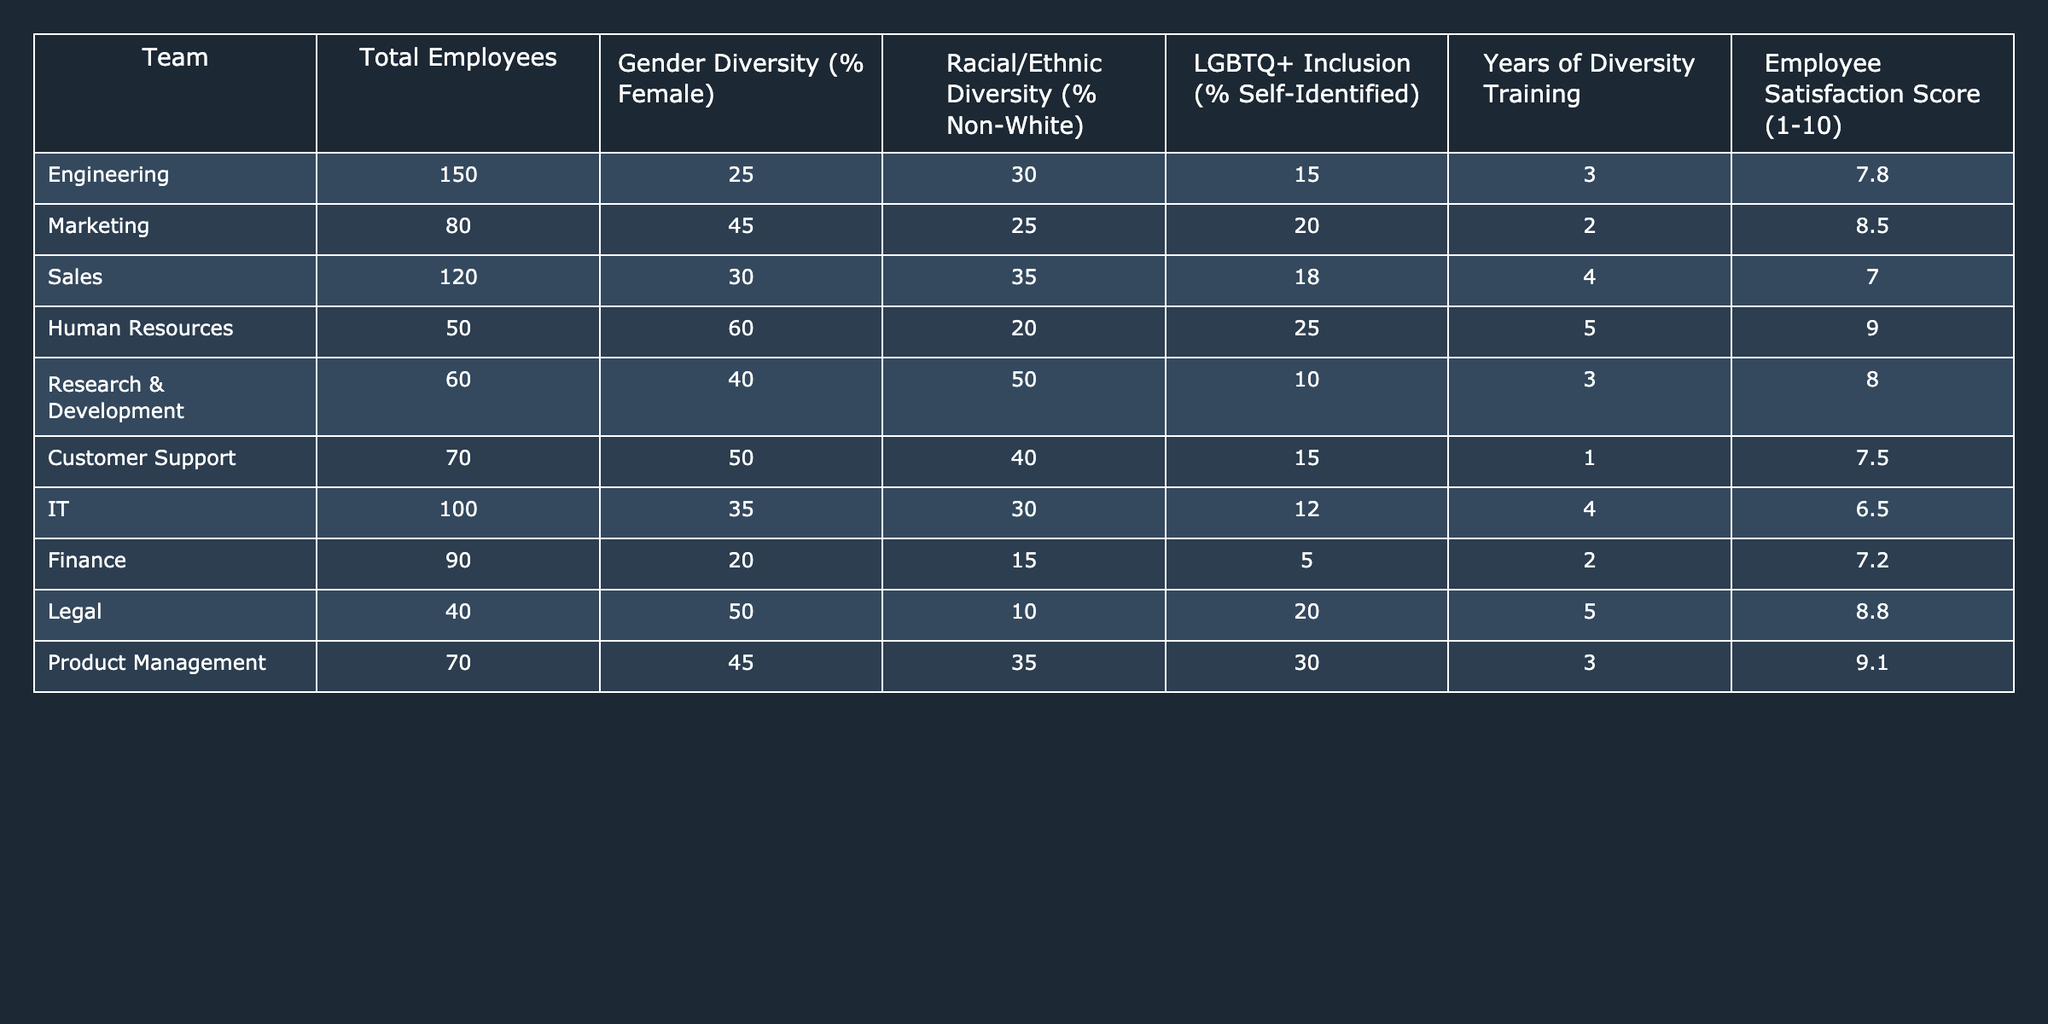What is the employee satisfaction score for the Legal team? The table shows the "Employee Satisfaction Score" for each team. For the Legal team, the corresponding score is listed directly as 8.8.
Answer: 8.8 What percentage of gender diversity is present in the Marketing team? The Marketing team's gender diversity percentage is directly provided in the table as 45%.
Answer: 45% Which team has the highest percentage of LGBTQ+ inclusion? By comparing the percentage of LGBTQ+ inclusion across all teams in the table, the Product Management team shows the highest at 30%.
Answer: 30% How many total employees work in the Human Resources team? The total number of employees in the Human Resources team is listed in the table as 50.
Answer: 50 Calculate the average employee satisfaction score across all teams. To find the average, sum the satisfaction scores: (7.8 + 8.5 + 7.0 + 9.0 + 8.0 + 7.5 + 6.5 + 7.2 + 8.8 + 9.1) = 79.4, then divide by the number of teams (10): 79.4 / 10 = 7.94.
Answer: 7.94 True or False: The IT team has a higher percentage of racial/ethnic diversity than the Finance team. The IT team's racial/ethnic diversity is 30%, and the Finance team's is 15%. Since 30% is greater than 15%, the statement is true.
Answer: True Which team shows the lowest percentage of gender diversity, and what is that percentage? By examining the table, the Finance team is identified as having the lowest gender diversity at 20%.
Answer: Finance, 20% What is the difference in employee satisfaction scores between the Engineering team and the Sales team? The Engineering team's satisfaction score is 7.8, while the Sales team’s is 7.0. The difference is calculated as 7.8 - 7.0 = 0.8.
Answer: 0.8 List the teams that have received more than four years of diversity training. A review of the table shows that the Human Resources team (5 years) and the Sales team (4 years) have received more than four years of diversity training, while others have received less.
Answer: Human Resources, Sales Identify the teams that have both a gender diversity percentage above 40% and an employee satisfaction score above 8. The teams that meet both criteria are Marketing (45%, 8.5), Human Resources (60%, 9.0), and Product Management (45%, 9.1).
Answer: Marketing, Human Resources, Product Management 